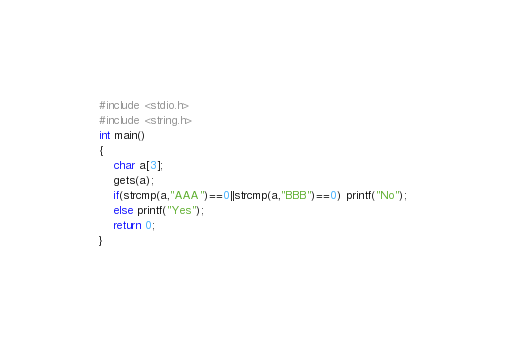Convert code to text. <code><loc_0><loc_0><loc_500><loc_500><_C_>#include <stdio.h>
#include <string.h>
int main()
{
	char a[3];
	gets(a);
	if(strcmp(a,"AAA")==0||strcmp(a,"BBB")==0) printf("No");
	else printf("Yes"); 
	return 0;
}</code> 